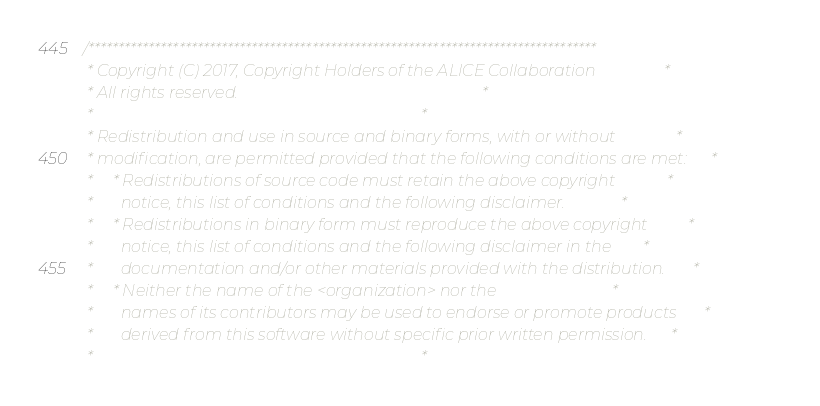<code> <loc_0><loc_0><loc_500><loc_500><_C++_>/************************************************************************************
 * Copyright (C) 2017, Copyright Holders of the ALICE Collaboration                 *
 * All rights reserved.                                                             *
 *                                                                                  *
 * Redistribution and use in source and binary forms, with or without               *
 * modification, are permitted provided that the following conditions are met:      *
 *     * Redistributions of source code must retain the above copyright             *
 *       notice, this list of conditions and the following disclaimer.              *
 *     * Redistributions in binary form must reproduce the above copyright          *
 *       notice, this list of conditions and the following disclaimer in the        *
 *       documentation and/or other materials provided with the distribution.       *
 *     * Neither the name of the <organization> nor the                             *
 *       names of its contributors may be used to endorse or promote products       *
 *       derived from this software without specific prior written permission.      *
 *                                                                                  *</code> 